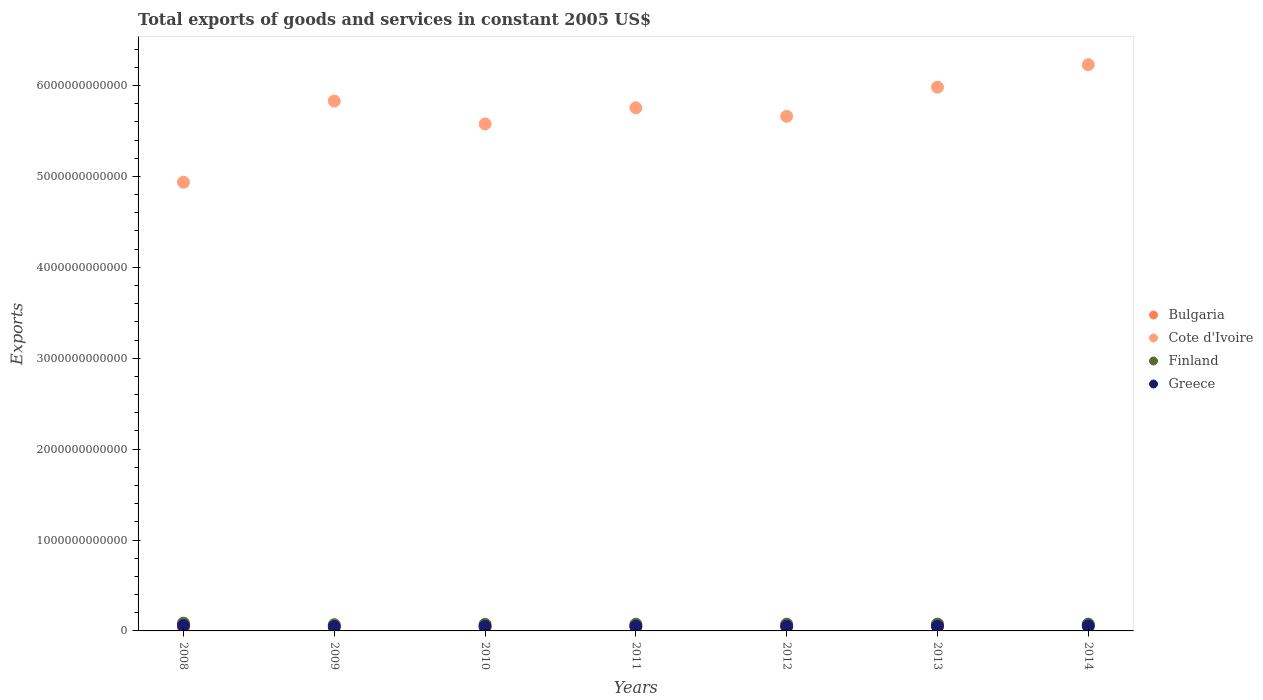How many different coloured dotlines are there?
Ensure brevity in your answer.  4. What is the total exports of goods and services in Finland in 2009?
Provide a succinct answer. 6.82e+1. Across all years, what is the maximum total exports of goods and services in Bulgaria?
Your answer should be very brief. 4.86e+1. Across all years, what is the minimum total exports of goods and services in Bulgaria?
Your answer should be compact. 3.38e+1. In which year was the total exports of goods and services in Finland minimum?
Provide a succinct answer. 2009. What is the total total exports of goods and services in Greece in the graph?
Give a very brief answer. 3.64e+11. What is the difference between the total exports of goods and services in Finland in 2009 and that in 2010?
Provide a succinct answer. -4.21e+09. What is the difference between the total exports of goods and services in Finland in 2008 and the total exports of goods and services in Bulgaria in 2012?
Your answer should be compact. 4.07e+1. What is the average total exports of goods and services in Finland per year?
Your response must be concise. 7.50e+1. In the year 2012, what is the difference between the total exports of goods and services in Finland and total exports of goods and services in Cote d'Ivoire?
Give a very brief answer. -5.59e+12. In how many years, is the total exports of goods and services in Finland greater than 6200000000000 US$?
Make the answer very short. 0. What is the ratio of the total exports of goods and services in Cote d'Ivoire in 2009 to that in 2010?
Offer a very short reply. 1.05. What is the difference between the highest and the second highest total exports of goods and services in Bulgaria?
Keep it short and to the point. 5.41e+07. What is the difference between the highest and the lowest total exports of goods and services in Finland?
Provide a succinct answer. 1.71e+1. Is the sum of the total exports of goods and services in Cote d'Ivoire in 2009 and 2014 greater than the maximum total exports of goods and services in Greece across all years?
Make the answer very short. Yes. Is it the case that in every year, the sum of the total exports of goods and services in Cote d'Ivoire and total exports of goods and services in Greece  is greater than the sum of total exports of goods and services in Bulgaria and total exports of goods and services in Finland?
Keep it short and to the point. No. Does the total exports of goods and services in Bulgaria monotonically increase over the years?
Offer a very short reply. No. Is the total exports of goods and services in Cote d'Ivoire strictly greater than the total exports of goods and services in Bulgaria over the years?
Give a very brief answer. Yes. Is the total exports of goods and services in Finland strictly less than the total exports of goods and services in Bulgaria over the years?
Keep it short and to the point. No. What is the difference between two consecutive major ticks on the Y-axis?
Offer a terse response. 1.00e+12. Does the graph contain any zero values?
Your answer should be compact. No. Does the graph contain grids?
Offer a terse response. No. How many legend labels are there?
Keep it short and to the point. 4. How are the legend labels stacked?
Give a very brief answer. Vertical. What is the title of the graph?
Keep it short and to the point. Total exports of goods and services in constant 2005 US$. What is the label or title of the X-axis?
Keep it short and to the point. Years. What is the label or title of the Y-axis?
Offer a very short reply. Exports. What is the Exports of Bulgaria in 2008?
Your answer should be very brief. 3.83e+1. What is the Exports in Cote d'Ivoire in 2008?
Provide a short and direct response. 4.94e+12. What is the Exports of Finland in 2008?
Your answer should be compact. 8.53e+1. What is the Exports in Greece in 2008?
Give a very brief answer. 5.85e+1. What is the Exports of Bulgaria in 2009?
Your answer should be very brief. 3.38e+1. What is the Exports in Cote d'Ivoire in 2009?
Provide a succinct answer. 5.83e+12. What is the Exports of Finland in 2009?
Offer a very short reply. 6.82e+1. What is the Exports in Greece in 2009?
Your response must be concise. 4.76e+1. What is the Exports in Bulgaria in 2010?
Ensure brevity in your answer.  3.96e+1. What is the Exports of Cote d'Ivoire in 2010?
Provide a short and direct response. 5.58e+12. What is the Exports in Finland in 2010?
Your answer should be compact. 7.24e+1. What is the Exports in Greece in 2010?
Give a very brief answer. 5.00e+1. What is the Exports in Bulgaria in 2011?
Give a very brief answer. 4.42e+1. What is the Exports of Cote d'Ivoire in 2011?
Your answer should be compact. 5.76e+12. What is the Exports in Finland in 2011?
Your answer should be very brief. 7.38e+1. What is the Exports of Greece in 2011?
Your answer should be compact. 5.00e+1. What is the Exports of Bulgaria in 2012?
Your answer should be very brief. 4.46e+1. What is the Exports in Cote d'Ivoire in 2012?
Offer a very short reply. 5.66e+12. What is the Exports of Finland in 2012?
Your answer should be very brief. 7.47e+1. What is the Exports in Greece in 2012?
Make the answer very short. 5.06e+1. What is the Exports of Bulgaria in 2013?
Provide a short and direct response. 4.86e+1. What is the Exports of Cote d'Ivoire in 2013?
Your response must be concise. 5.98e+12. What is the Exports in Finland in 2013?
Give a very brief answer. 7.56e+1. What is the Exports of Greece in 2013?
Your response must be concise. 5.17e+1. What is the Exports of Bulgaria in 2014?
Your answer should be compact. 4.86e+1. What is the Exports in Cote d'Ivoire in 2014?
Keep it short and to the point. 6.23e+12. What is the Exports in Finland in 2014?
Your answer should be very brief. 7.50e+1. What is the Exports in Greece in 2014?
Give a very brief answer. 5.55e+1. Across all years, what is the maximum Exports of Bulgaria?
Offer a terse response. 4.86e+1. Across all years, what is the maximum Exports in Cote d'Ivoire?
Your answer should be very brief. 6.23e+12. Across all years, what is the maximum Exports of Finland?
Offer a very short reply. 8.53e+1. Across all years, what is the maximum Exports of Greece?
Your response must be concise. 5.85e+1. Across all years, what is the minimum Exports in Bulgaria?
Your answer should be very brief. 3.38e+1. Across all years, what is the minimum Exports of Cote d'Ivoire?
Your response must be concise. 4.94e+12. Across all years, what is the minimum Exports in Finland?
Your response must be concise. 6.82e+1. Across all years, what is the minimum Exports of Greece?
Your answer should be compact. 4.76e+1. What is the total Exports of Bulgaria in the graph?
Keep it short and to the point. 2.98e+11. What is the total Exports in Cote d'Ivoire in the graph?
Your answer should be compact. 4.00e+13. What is the total Exports of Finland in the graph?
Make the answer very short. 5.25e+11. What is the total Exports in Greece in the graph?
Keep it short and to the point. 3.64e+11. What is the difference between the Exports in Bulgaria in 2008 and that in 2009?
Keep it short and to the point. 4.49e+09. What is the difference between the Exports in Cote d'Ivoire in 2008 and that in 2009?
Offer a very short reply. -8.94e+11. What is the difference between the Exports of Finland in 2008 and that in 2009?
Provide a succinct answer. 1.71e+1. What is the difference between the Exports of Greece in 2008 and that in 2009?
Offer a very short reply. 1.08e+1. What is the difference between the Exports of Bulgaria in 2008 and that in 2010?
Make the answer very short. -1.33e+09. What is the difference between the Exports in Cote d'Ivoire in 2008 and that in 2010?
Offer a terse response. -6.42e+11. What is the difference between the Exports of Finland in 2008 and that in 2010?
Offer a terse response. 1.29e+1. What is the difference between the Exports in Greece in 2008 and that in 2010?
Make the answer very short. 8.51e+09. What is the difference between the Exports in Bulgaria in 2008 and that in 2011?
Your answer should be compact. -5.89e+09. What is the difference between the Exports of Cote d'Ivoire in 2008 and that in 2011?
Ensure brevity in your answer.  -8.19e+11. What is the difference between the Exports in Finland in 2008 and that in 2011?
Your answer should be very brief. 1.15e+1. What is the difference between the Exports in Greece in 2008 and that in 2011?
Offer a terse response. 8.50e+09. What is the difference between the Exports in Bulgaria in 2008 and that in 2012?
Provide a short and direct response. -6.23e+09. What is the difference between the Exports of Cote d'Ivoire in 2008 and that in 2012?
Offer a very short reply. -7.26e+11. What is the difference between the Exports in Finland in 2008 and that in 2012?
Make the answer very short. 1.06e+1. What is the difference between the Exports in Greece in 2008 and that in 2012?
Your answer should be compact. 7.91e+09. What is the difference between the Exports of Bulgaria in 2008 and that in 2013?
Your answer should be very brief. -1.03e+1. What is the difference between the Exports of Cote d'Ivoire in 2008 and that in 2013?
Ensure brevity in your answer.  -1.05e+12. What is the difference between the Exports in Finland in 2008 and that in 2013?
Keep it short and to the point. 9.71e+09. What is the difference between the Exports of Greece in 2008 and that in 2013?
Your answer should be very brief. 6.82e+09. What is the difference between the Exports in Bulgaria in 2008 and that in 2014?
Ensure brevity in your answer.  -1.03e+1. What is the difference between the Exports of Cote d'Ivoire in 2008 and that in 2014?
Offer a very short reply. -1.29e+12. What is the difference between the Exports of Finland in 2008 and that in 2014?
Offer a terse response. 1.03e+1. What is the difference between the Exports in Greece in 2008 and that in 2014?
Your answer should be compact. 2.96e+09. What is the difference between the Exports of Bulgaria in 2009 and that in 2010?
Offer a terse response. -5.82e+09. What is the difference between the Exports in Cote d'Ivoire in 2009 and that in 2010?
Ensure brevity in your answer.  2.52e+11. What is the difference between the Exports of Finland in 2009 and that in 2010?
Provide a succinct answer. -4.21e+09. What is the difference between the Exports of Greece in 2009 and that in 2010?
Give a very brief answer. -2.32e+09. What is the difference between the Exports of Bulgaria in 2009 and that in 2011?
Your answer should be very brief. -1.04e+1. What is the difference between the Exports in Cote d'Ivoire in 2009 and that in 2011?
Make the answer very short. 7.47e+1. What is the difference between the Exports in Finland in 2009 and that in 2011?
Make the answer very short. -5.65e+09. What is the difference between the Exports of Greece in 2009 and that in 2011?
Offer a very short reply. -2.33e+09. What is the difference between the Exports of Bulgaria in 2009 and that in 2012?
Provide a short and direct response. -1.07e+1. What is the difference between the Exports of Cote d'Ivoire in 2009 and that in 2012?
Your answer should be compact. 1.68e+11. What is the difference between the Exports of Finland in 2009 and that in 2012?
Make the answer very short. -6.56e+09. What is the difference between the Exports of Greece in 2009 and that in 2012?
Offer a very short reply. -2.92e+09. What is the difference between the Exports in Bulgaria in 2009 and that in 2013?
Your answer should be very brief. -1.48e+1. What is the difference between the Exports of Cote d'Ivoire in 2009 and that in 2013?
Keep it short and to the point. -1.53e+11. What is the difference between the Exports of Finland in 2009 and that in 2013?
Make the answer very short. -7.42e+09. What is the difference between the Exports of Greece in 2009 and that in 2013?
Offer a terse response. -4.01e+09. What is the difference between the Exports of Bulgaria in 2009 and that in 2014?
Provide a succinct answer. -1.48e+1. What is the difference between the Exports in Cote d'Ivoire in 2009 and that in 2014?
Your response must be concise. -3.99e+11. What is the difference between the Exports of Finland in 2009 and that in 2014?
Provide a short and direct response. -6.86e+09. What is the difference between the Exports in Greece in 2009 and that in 2014?
Provide a succinct answer. -7.87e+09. What is the difference between the Exports of Bulgaria in 2010 and that in 2011?
Your answer should be compact. -4.56e+09. What is the difference between the Exports of Cote d'Ivoire in 2010 and that in 2011?
Offer a terse response. -1.77e+11. What is the difference between the Exports of Finland in 2010 and that in 2011?
Your answer should be very brief. -1.44e+09. What is the difference between the Exports of Greece in 2010 and that in 2011?
Keep it short and to the point. -1.36e+07. What is the difference between the Exports of Bulgaria in 2010 and that in 2012?
Your answer should be compact. -4.91e+09. What is the difference between the Exports of Cote d'Ivoire in 2010 and that in 2012?
Ensure brevity in your answer.  -8.40e+1. What is the difference between the Exports in Finland in 2010 and that in 2012?
Provide a succinct answer. -2.35e+09. What is the difference between the Exports in Greece in 2010 and that in 2012?
Your answer should be very brief. -6.00e+08. What is the difference between the Exports in Bulgaria in 2010 and that in 2013?
Ensure brevity in your answer.  -9.00e+09. What is the difference between the Exports in Cote d'Ivoire in 2010 and that in 2013?
Provide a succinct answer. -4.04e+11. What is the difference between the Exports of Finland in 2010 and that in 2013?
Keep it short and to the point. -3.21e+09. What is the difference between the Exports in Greece in 2010 and that in 2013?
Provide a succinct answer. -1.70e+09. What is the difference between the Exports of Bulgaria in 2010 and that in 2014?
Provide a succinct answer. -8.95e+09. What is the difference between the Exports in Cote d'Ivoire in 2010 and that in 2014?
Offer a terse response. -6.51e+11. What is the difference between the Exports of Finland in 2010 and that in 2014?
Keep it short and to the point. -2.64e+09. What is the difference between the Exports of Greece in 2010 and that in 2014?
Offer a very short reply. -5.55e+09. What is the difference between the Exports of Bulgaria in 2011 and that in 2012?
Offer a terse response. -3.45e+08. What is the difference between the Exports in Cote d'Ivoire in 2011 and that in 2012?
Give a very brief answer. 9.32e+1. What is the difference between the Exports of Finland in 2011 and that in 2012?
Make the answer very short. -9.15e+08. What is the difference between the Exports in Greece in 2011 and that in 2012?
Offer a terse response. -5.86e+08. What is the difference between the Exports of Bulgaria in 2011 and that in 2013?
Your response must be concise. -4.44e+09. What is the difference between the Exports of Cote d'Ivoire in 2011 and that in 2013?
Your response must be concise. -2.27e+11. What is the difference between the Exports in Finland in 2011 and that in 2013?
Your answer should be very brief. -1.77e+09. What is the difference between the Exports in Greece in 2011 and that in 2013?
Offer a very short reply. -1.68e+09. What is the difference between the Exports of Bulgaria in 2011 and that in 2014?
Your answer should be compact. -4.38e+09. What is the difference between the Exports in Cote d'Ivoire in 2011 and that in 2014?
Offer a terse response. -4.74e+11. What is the difference between the Exports in Finland in 2011 and that in 2014?
Provide a short and direct response. -1.21e+09. What is the difference between the Exports of Greece in 2011 and that in 2014?
Provide a short and direct response. -5.54e+09. What is the difference between the Exports in Bulgaria in 2012 and that in 2013?
Provide a short and direct response. -4.09e+09. What is the difference between the Exports of Cote d'Ivoire in 2012 and that in 2013?
Ensure brevity in your answer.  -3.20e+11. What is the difference between the Exports of Finland in 2012 and that in 2013?
Provide a succinct answer. -8.58e+08. What is the difference between the Exports in Greece in 2012 and that in 2013?
Your answer should be very brief. -1.10e+09. What is the difference between the Exports of Bulgaria in 2012 and that in 2014?
Provide a succinct answer. -4.04e+09. What is the difference between the Exports in Cote d'Ivoire in 2012 and that in 2014?
Give a very brief answer. -5.67e+11. What is the difference between the Exports in Finland in 2012 and that in 2014?
Give a very brief answer. -2.92e+08. What is the difference between the Exports in Greece in 2012 and that in 2014?
Provide a short and direct response. -4.95e+09. What is the difference between the Exports of Bulgaria in 2013 and that in 2014?
Make the answer very short. 5.41e+07. What is the difference between the Exports of Cote d'Ivoire in 2013 and that in 2014?
Your answer should be compact. -2.47e+11. What is the difference between the Exports in Finland in 2013 and that in 2014?
Provide a succinct answer. 5.66e+08. What is the difference between the Exports of Greece in 2013 and that in 2014?
Your response must be concise. -3.86e+09. What is the difference between the Exports of Bulgaria in 2008 and the Exports of Cote d'Ivoire in 2009?
Ensure brevity in your answer.  -5.79e+12. What is the difference between the Exports of Bulgaria in 2008 and the Exports of Finland in 2009?
Provide a succinct answer. -2.98e+1. What is the difference between the Exports of Bulgaria in 2008 and the Exports of Greece in 2009?
Keep it short and to the point. -9.32e+09. What is the difference between the Exports in Cote d'Ivoire in 2008 and the Exports in Finland in 2009?
Ensure brevity in your answer.  4.87e+12. What is the difference between the Exports of Cote d'Ivoire in 2008 and the Exports of Greece in 2009?
Give a very brief answer. 4.89e+12. What is the difference between the Exports in Finland in 2008 and the Exports in Greece in 2009?
Give a very brief answer. 3.76e+1. What is the difference between the Exports in Bulgaria in 2008 and the Exports in Cote d'Ivoire in 2010?
Give a very brief answer. -5.54e+12. What is the difference between the Exports of Bulgaria in 2008 and the Exports of Finland in 2010?
Your answer should be compact. -3.40e+1. What is the difference between the Exports in Bulgaria in 2008 and the Exports in Greece in 2010?
Offer a terse response. -1.16e+1. What is the difference between the Exports of Cote d'Ivoire in 2008 and the Exports of Finland in 2010?
Give a very brief answer. 4.86e+12. What is the difference between the Exports in Cote d'Ivoire in 2008 and the Exports in Greece in 2010?
Ensure brevity in your answer.  4.89e+12. What is the difference between the Exports of Finland in 2008 and the Exports of Greece in 2010?
Your answer should be very brief. 3.53e+1. What is the difference between the Exports in Bulgaria in 2008 and the Exports in Cote d'Ivoire in 2011?
Your answer should be very brief. -5.72e+12. What is the difference between the Exports in Bulgaria in 2008 and the Exports in Finland in 2011?
Offer a terse response. -3.55e+1. What is the difference between the Exports in Bulgaria in 2008 and the Exports in Greece in 2011?
Provide a short and direct response. -1.16e+1. What is the difference between the Exports in Cote d'Ivoire in 2008 and the Exports in Finland in 2011?
Keep it short and to the point. 4.86e+12. What is the difference between the Exports of Cote d'Ivoire in 2008 and the Exports of Greece in 2011?
Offer a very short reply. 4.89e+12. What is the difference between the Exports in Finland in 2008 and the Exports in Greece in 2011?
Offer a very short reply. 3.53e+1. What is the difference between the Exports in Bulgaria in 2008 and the Exports in Cote d'Ivoire in 2012?
Keep it short and to the point. -5.62e+12. What is the difference between the Exports in Bulgaria in 2008 and the Exports in Finland in 2012?
Make the answer very short. -3.64e+1. What is the difference between the Exports of Bulgaria in 2008 and the Exports of Greece in 2012?
Your answer should be very brief. -1.22e+1. What is the difference between the Exports in Cote d'Ivoire in 2008 and the Exports in Finland in 2012?
Give a very brief answer. 4.86e+12. What is the difference between the Exports of Cote d'Ivoire in 2008 and the Exports of Greece in 2012?
Your answer should be very brief. 4.89e+12. What is the difference between the Exports in Finland in 2008 and the Exports in Greece in 2012?
Offer a very short reply. 3.47e+1. What is the difference between the Exports of Bulgaria in 2008 and the Exports of Cote d'Ivoire in 2013?
Offer a very short reply. -5.94e+12. What is the difference between the Exports of Bulgaria in 2008 and the Exports of Finland in 2013?
Your answer should be compact. -3.73e+1. What is the difference between the Exports of Bulgaria in 2008 and the Exports of Greece in 2013?
Provide a succinct answer. -1.33e+1. What is the difference between the Exports in Cote d'Ivoire in 2008 and the Exports in Finland in 2013?
Keep it short and to the point. 4.86e+12. What is the difference between the Exports of Cote d'Ivoire in 2008 and the Exports of Greece in 2013?
Offer a very short reply. 4.88e+12. What is the difference between the Exports in Finland in 2008 and the Exports in Greece in 2013?
Offer a terse response. 3.36e+1. What is the difference between the Exports of Bulgaria in 2008 and the Exports of Cote d'Ivoire in 2014?
Provide a short and direct response. -6.19e+12. What is the difference between the Exports in Bulgaria in 2008 and the Exports in Finland in 2014?
Offer a very short reply. -3.67e+1. What is the difference between the Exports of Bulgaria in 2008 and the Exports of Greece in 2014?
Your answer should be compact. -1.72e+1. What is the difference between the Exports in Cote d'Ivoire in 2008 and the Exports in Finland in 2014?
Your response must be concise. 4.86e+12. What is the difference between the Exports of Cote d'Ivoire in 2008 and the Exports of Greece in 2014?
Offer a terse response. 4.88e+12. What is the difference between the Exports of Finland in 2008 and the Exports of Greece in 2014?
Provide a short and direct response. 2.98e+1. What is the difference between the Exports of Bulgaria in 2009 and the Exports of Cote d'Ivoire in 2010?
Keep it short and to the point. -5.54e+12. What is the difference between the Exports of Bulgaria in 2009 and the Exports of Finland in 2010?
Your answer should be compact. -3.85e+1. What is the difference between the Exports in Bulgaria in 2009 and the Exports in Greece in 2010?
Ensure brevity in your answer.  -1.61e+1. What is the difference between the Exports of Cote d'Ivoire in 2009 and the Exports of Finland in 2010?
Keep it short and to the point. 5.76e+12. What is the difference between the Exports of Cote d'Ivoire in 2009 and the Exports of Greece in 2010?
Keep it short and to the point. 5.78e+12. What is the difference between the Exports of Finland in 2009 and the Exports of Greece in 2010?
Provide a short and direct response. 1.82e+1. What is the difference between the Exports of Bulgaria in 2009 and the Exports of Cote d'Ivoire in 2011?
Give a very brief answer. -5.72e+12. What is the difference between the Exports of Bulgaria in 2009 and the Exports of Finland in 2011?
Make the answer very short. -4.00e+1. What is the difference between the Exports in Bulgaria in 2009 and the Exports in Greece in 2011?
Make the answer very short. -1.61e+1. What is the difference between the Exports of Cote d'Ivoire in 2009 and the Exports of Finland in 2011?
Make the answer very short. 5.76e+12. What is the difference between the Exports of Cote d'Ivoire in 2009 and the Exports of Greece in 2011?
Keep it short and to the point. 5.78e+12. What is the difference between the Exports in Finland in 2009 and the Exports in Greece in 2011?
Ensure brevity in your answer.  1.82e+1. What is the difference between the Exports in Bulgaria in 2009 and the Exports in Cote d'Ivoire in 2012?
Ensure brevity in your answer.  -5.63e+12. What is the difference between the Exports in Bulgaria in 2009 and the Exports in Finland in 2012?
Offer a very short reply. -4.09e+1. What is the difference between the Exports in Bulgaria in 2009 and the Exports in Greece in 2012?
Your answer should be very brief. -1.67e+1. What is the difference between the Exports of Cote d'Ivoire in 2009 and the Exports of Finland in 2012?
Ensure brevity in your answer.  5.75e+12. What is the difference between the Exports of Cote d'Ivoire in 2009 and the Exports of Greece in 2012?
Ensure brevity in your answer.  5.78e+12. What is the difference between the Exports in Finland in 2009 and the Exports in Greece in 2012?
Provide a succinct answer. 1.76e+1. What is the difference between the Exports in Bulgaria in 2009 and the Exports in Cote d'Ivoire in 2013?
Keep it short and to the point. -5.95e+12. What is the difference between the Exports of Bulgaria in 2009 and the Exports of Finland in 2013?
Offer a terse response. -4.17e+1. What is the difference between the Exports in Bulgaria in 2009 and the Exports in Greece in 2013?
Offer a very short reply. -1.78e+1. What is the difference between the Exports of Cote d'Ivoire in 2009 and the Exports of Finland in 2013?
Provide a succinct answer. 5.75e+12. What is the difference between the Exports in Cote d'Ivoire in 2009 and the Exports in Greece in 2013?
Provide a short and direct response. 5.78e+12. What is the difference between the Exports in Finland in 2009 and the Exports in Greece in 2013?
Ensure brevity in your answer.  1.65e+1. What is the difference between the Exports in Bulgaria in 2009 and the Exports in Cote d'Ivoire in 2014?
Provide a succinct answer. -6.20e+12. What is the difference between the Exports in Bulgaria in 2009 and the Exports in Finland in 2014?
Your response must be concise. -4.12e+1. What is the difference between the Exports in Bulgaria in 2009 and the Exports in Greece in 2014?
Offer a very short reply. -2.17e+1. What is the difference between the Exports of Cote d'Ivoire in 2009 and the Exports of Finland in 2014?
Provide a short and direct response. 5.75e+12. What is the difference between the Exports of Cote d'Ivoire in 2009 and the Exports of Greece in 2014?
Your response must be concise. 5.77e+12. What is the difference between the Exports in Finland in 2009 and the Exports in Greece in 2014?
Make the answer very short. 1.26e+1. What is the difference between the Exports in Bulgaria in 2010 and the Exports in Cote d'Ivoire in 2011?
Provide a short and direct response. -5.72e+12. What is the difference between the Exports in Bulgaria in 2010 and the Exports in Finland in 2011?
Give a very brief answer. -3.42e+1. What is the difference between the Exports in Bulgaria in 2010 and the Exports in Greece in 2011?
Provide a short and direct response. -1.03e+1. What is the difference between the Exports of Cote d'Ivoire in 2010 and the Exports of Finland in 2011?
Your response must be concise. 5.50e+12. What is the difference between the Exports of Cote d'Ivoire in 2010 and the Exports of Greece in 2011?
Offer a very short reply. 5.53e+12. What is the difference between the Exports of Finland in 2010 and the Exports of Greece in 2011?
Your answer should be compact. 2.24e+1. What is the difference between the Exports in Bulgaria in 2010 and the Exports in Cote d'Ivoire in 2012?
Provide a succinct answer. -5.62e+12. What is the difference between the Exports in Bulgaria in 2010 and the Exports in Finland in 2012?
Give a very brief answer. -3.51e+1. What is the difference between the Exports of Bulgaria in 2010 and the Exports of Greece in 2012?
Keep it short and to the point. -1.09e+1. What is the difference between the Exports in Cote d'Ivoire in 2010 and the Exports in Finland in 2012?
Your answer should be compact. 5.50e+12. What is the difference between the Exports of Cote d'Ivoire in 2010 and the Exports of Greece in 2012?
Provide a succinct answer. 5.53e+12. What is the difference between the Exports in Finland in 2010 and the Exports in Greece in 2012?
Keep it short and to the point. 2.18e+1. What is the difference between the Exports in Bulgaria in 2010 and the Exports in Cote d'Ivoire in 2013?
Give a very brief answer. -5.94e+12. What is the difference between the Exports of Bulgaria in 2010 and the Exports of Finland in 2013?
Provide a succinct answer. -3.59e+1. What is the difference between the Exports of Bulgaria in 2010 and the Exports of Greece in 2013?
Offer a terse response. -1.20e+1. What is the difference between the Exports in Cote d'Ivoire in 2010 and the Exports in Finland in 2013?
Offer a very short reply. 5.50e+12. What is the difference between the Exports of Cote d'Ivoire in 2010 and the Exports of Greece in 2013?
Provide a succinct answer. 5.53e+12. What is the difference between the Exports in Finland in 2010 and the Exports in Greece in 2013?
Your response must be concise. 2.07e+1. What is the difference between the Exports of Bulgaria in 2010 and the Exports of Cote d'Ivoire in 2014?
Ensure brevity in your answer.  -6.19e+12. What is the difference between the Exports of Bulgaria in 2010 and the Exports of Finland in 2014?
Your answer should be very brief. -3.54e+1. What is the difference between the Exports of Bulgaria in 2010 and the Exports of Greece in 2014?
Give a very brief answer. -1.59e+1. What is the difference between the Exports of Cote d'Ivoire in 2010 and the Exports of Finland in 2014?
Offer a terse response. 5.50e+12. What is the difference between the Exports of Cote d'Ivoire in 2010 and the Exports of Greece in 2014?
Offer a very short reply. 5.52e+12. What is the difference between the Exports in Finland in 2010 and the Exports in Greece in 2014?
Ensure brevity in your answer.  1.69e+1. What is the difference between the Exports of Bulgaria in 2011 and the Exports of Cote d'Ivoire in 2012?
Keep it short and to the point. -5.62e+12. What is the difference between the Exports of Bulgaria in 2011 and the Exports of Finland in 2012?
Offer a very short reply. -3.05e+1. What is the difference between the Exports in Bulgaria in 2011 and the Exports in Greece in 2012?
Keep it short and to the point. -6.35e+09. What is the difference between the Exports in Cote d'Ivoire in 2011 and the Exports in Finland in 2012?
Your answer should be compact. 5.68e+12. What is the difference between the Exports of Cote d'Ivoire in 2011 and the Exports of Greece in 2012?
Offer a very short reply. 5.70e+12. What is the difference between the Exports in Finland in 2011 and the Exports in Greece in 2012?
Keep it short and to the point. 2.32e+1. What is the difference between the Exports in Bulgaria in 2011 and the Exports in Cote d'Ivoire in 2013?
Provide a short and direct response. -5.94e+12. What is the difference between the Exports of Bulgaria in 2011 and the Exports of Finland in 2013?
Ensure brevity in your answer.  -3.14e+1. What is the difference between the Exports of Bulgaria in 2011 and the Exports of Greece in 2013?
Provide a succinct answer. -7.44e+09. What is the difference between the Exports in Cote d'Ivoire in 2011 and the Exports in Finland in 2013?
Offer a terse response. 5.68e+12. What is the difference between the Exports in Cote d'Ivoire in 2011 and the Exports in Greece in 2013?
Keep it short and to the point. 5.70e+12. What is the difference between the Exports in Finland in 2011 and the Exports in Greece in 2013?
Your answer should be very brief. 2.21e+1. What is the difference between the Exports of Bulgaria in 2011 and the Exports of Cote d'Ivoire in 2014?
Provide a short and direct response. -6.18e+12. What is the difference between the Exports of Bulgaria in 2011 and the Exports of Finland in 2014?
Provide a succinct answer. -3.08e+1. What is the difference between the Exports of Bulgaria in 2011 and the Exports of Greece in 2014?
Ensure brevity in your answer.  -1.13e+1. What is the difference between the Exports in Cote d'Ivoire in 2011 and the Exports in Finland in 2014?
Ensure brevity in your answer.  5.68e+12. What is the difference between the Exports in Cote d'Ivoire in 2011 and the Exports in Greece in 2014?
Provide a succinct answer. 5.70e+12. What is the difference between the Exports of Finland in 2011 and the Exports of Greece in 2014?
Ensure brevity in your answer.  1.83e+1. What is the difference between the Exports of Bulgaria in 2012 and the Exports of Cote d'Ivoire in 2013?
Your answer should be compact. -5.94e+12. What is the difference between the Exports in Bulgaria in 2012 and the Exports in Finland in 2013?
Your response must be concise. -3.10e+1. What is the difference between the Exports in Bulgaria in 2012 and the Exports in Greece in 2013?
Provide a short and direct response. -7.10e+09. What is the difference between the Exports of Cote d'Ivoire in 2012 and the Exports of Finland in 2013?
Offer a very short reply. 5.59e+12. What is the difference between the Exports in Cote d'Ivoire in 2012 and the Exports in Greece in 2013?
Give a very brief answer. 5.61e+12. What is the difference between the Exports of Finland in 2012 and the Exports of Greece in 2013?
Give a very brief answer. 2.31e+1. What is the difference between the Exports of Bulgaria in 2012 and the Exports of Cote d'Ivoire in 2014?
Your response must be concise. -6.18e+12. What is the difference between the Exports in Bulgaria in 2012 and the Exports in Finland in 2014?
Keep it short and to the point. -3.05e+1. What is the difference between the Exports in Bulgaria in 2012 and the Exports in Greece in 2014?
Make the answer very short. -1.10e+1. What is the difference between the Exports of Cote d'Ivoire in 2012 and the Exports of Finland in 2014?
Provide a succinct answer. 5.59e+12. What is the difference between the Exports of Cote d'Ivoire in 2012 and the Exports of Greece in 2014?
Provide a succinct answer. 5.61e+12. What is the difference between the Exports in Finland in 2012 and the Exports in Greece in 2014?
Your answer should be very brief. 1.92e+1. What is the difference between the Exports in Bulgaria in 2013 and the Exports in Cote d'Ivoire in 2014?
Keep it short and to the point. -6.18e+12. What is the difference between the Exports in Bulgaria in 2013 and the Exports in Finland in 2014?
Give a very brief answer. -2.64e+1. What is the difference between the Exports in Bulgaria in 2013 and the Exports in Greece in 2014?
Give a very brief answer. -6.86e+09. What is the difference between the Exports in Cote d'Ivoire in 2013 and the Exports in Finland in 2014?
Your answer should be compact. 5.91e+12. What is the difference between the Exports in Cote d'Ivoire in 2013 and the Exports in Greece in 2014?
Your response must be concise. 5.93e+12. What is the difference between the Exports of Finland in 2013 and the Exports of Greece in 2014?
Your response must be concise. 2.01e+1. What is the average Exports of Bulgaria per year?
Keep it short and to the point. 4.25e+1. What is the average Exports of Cote d'Ivoire per year?
Provide a short and direct response. 5.71e+12. What is the average Exports of Finland per year?
Ensure brevity in your answer.  7.50e+1. What is the average Exports in Greece per year?
Provide a succinct answer. 5.20e+1. In the year 2008, what is the difference between the Exports of Bulgaria and Exports of Cote d'Ivoire?
Your answer should be compact. -4.90e+12. In the year 2008, what is the difference between the Exports of Bulgaria and Exports of Finland?
Your answer should be compact. -4.70e+1. In the year 2008, what is the difference between the Exports in Bulgaria and Exports in Greece?
Keep it short and to the point. -2.01e+1. In the year 2008, what is the difference between the Exports of Cote d'Ivoire and Exports of Finland?
Provide a short and direct response. 4.85e+12. In the year 2008, what is the difference between the Exports of Cote d'Ivoire and Exports of Greece?
Ensure brevity in your answer.  4.88e+12. In the year 2008, what is the difference between the Exports in Finland and Exports in Greece?
Offer a terse response. 2.68e+1. In the year 2009, what is the difference between the Exports in Bulgaria and Exports in Cote d'Ivoire?
Keep it short and to the point. -5.80e+12. In the year 2009, what is the difference between the Exports of Bulgaria and Exports of Finland?
Your answer should be compact. -3.43e+1. In the year 2009, what is the difference between the Exports of Bulgaria and Exports of Greece?
Keep it short and to the point. -1.38e+1. In the year 2009, what is the difference between the Exports of Cote d'Ivoire and Exports of Finland?
Your answer should be very brief. 5.76e+12. In the year 2009, what is the difference between the Exports of Cote d'Ivoire and Exports of Greece?
Offer a very short reply. 5.78e+12. In the year 2009, what is the difference between the Exports of Finland and Exports of Greece?
Ensure brevity in your answer.  2.05e+1. In the year 2010, what is the difference between the Exports of Bulgaria and Exports of Cote d'Ivoire?
Offer a very short reply. -5.54e+12. In the year 2010, what is the difference between the Exports of Bulgaria and Exports of Finland?
Make the answer very short. -3.27e+1. In the year 2010, what is the difference between the Exports in Bulgaria and Exports in Greece?
Your answer should be compact. -1.03e+1. In the year 2010, what is the difference between the Exports in Cote d'Ivoire and Exports in Finland?
Your response must be concise. 5.51e+12. In the year 2010, what is the difference between the Exports of Cote d'Ivoire and Exports of Greece?
Your answer should be compact. 5.53e+12. In the year 2010, what is the difference between the Exports of Finland and Exports of Greece?
Provide a short and direct response. 2.24e+1. In the year 2011, what is the difference between the Exports in Bulgaria and Exports in Cote d'Ivoire?
Ensure brevity in your answer.  -5.71e+12. In the year 2011, what is the difference between the Exports in Bulgaria and Exports in Finland?
Provide a succinct answer. -2.96e+1. In the year 2011, what is the difference between the Exports of Bulgaria and Exports of Greece?
Offer a very short reply. -5.76e+09. In the year 2011, what is the difference between the Exports in Cote d'Ivoire and Exports in Finland?
Offer a very short reply. 5.68e+12. In the year 2011, what is the difference between the Exports of Cote d'Ivoire and Exports of Greece?
Your answer should be compact. 5.71e+12. In the year 2011, what is the difference between the Exports of Finland and Exports of Greece?
Offer a very short reply. 2.38e+1. In the year 2012, what is the difference between the Exports of Bulgaria and Exports of Cote d'Ivoire?
Keep it short and to the point. -5.62e+12. In the year 2012, what is the difference between the Exports of Bulgaria and Exports of Finland?
Keep it short and to the point. -3.02e+1. In the year 2012, what is the difference between the Exports of Bulgaria and Exports of Greece?
Ensure brevity in your answer.  -6.00e+09. In the year 2012, what is the difference between the Exports of Cote d'Ivoire and Exports of Finland?
Offer a very short reply. 5.59e+12. In the year 2012, what is the difference between the Exports in Cote d'Ivoire and Exports in Greece?
Your response must be concise. 5.61e+12. In the year 2012, what is the difference between the Exports in Finland and Exports in Greece?
Make the answer very short. 2.42e+1. In the year 2013, what is the difference between the Exports in Bulgaria and Exports in Cote d'Ivoire?
Ensure brevity in your answer.  -5.93e+12. In the year 2013, what is the difference between the Exports in Bulgaria and Exports in Finland?
Your response must be concise. -2.69e+1. In the year 2013, what is the difference between the Exports of Bulgaria and Exports of Greece?
Your response must be concise. -3.01e+09. In the year 2013, what is the difference between the Exports of Cote d'Ivoire and Exports of Finland?
Offer a terse response. 5.91e+12. In the year 2013, what is the difference between the Exports in Cote d'Ivoire and Exports in Greece?
Provide a short and direct response. 5.93e+12. In the year 2013, what is the difference between the Exports of Finland and Exports of Greece?
Provide a succinct answer. 2.39e+1. In the year 2014, what is the difference between the Exports in Bulgaria and Exports in Cote d'Ivoire?
Keep it short and to the point. -6.18e+12. In the year 2014, what is the difference between the Exports of Bulgaria and Exports of Finland?
Provide a succinct answer. -2.64e+1. In the year 2014, what is the difference between the Exports in Bulgaria and Exports in Greece?
Offer a terse response. -6.92e+09. In the year 2014, what is the difference between the Exports in Cote d'Ivoire and Exports in Finland?
Give a very brief answer. 6.15e+12. In the year 2014, what is the difference between the Exports in Cote d'Ivoire and Exports in Greece?
Offer a terse response. 6.17e+12. In the year 2014, what is the difference between the Exports in Finland and Exports in Greece?
Make the answer very short. 1.95e+1. What is the ratio of the Exports of Bulgaria in 2008 to that in 2009?
Keep it short and to the point. 1.13. What is the ratio of the Exports in Cote d'Ivoire in 2008 to that in 2009?
Your answer should be compact. 0.85. What is the ratio of the Exports in Finland in 2008 to that in 2009?
Your response must be concise. 1.25. What is the ratio of the Exports of Greece in 2008 to that in 2009?
Keep it short and to the point. 1.23. What is the ratio of the Exports of Bulgaria in 2008 to that in 2010?
Make the answer very short. 0.97. What is the ratio of the Exports of Cote d'Ivoire in 2008 to that in 2010?
Offer a very short reply. 0.89. What is the ratio of the Exports in Finland in 2008 to that in 2010?
Keep it short and to the point. 1.18. What is the ratio of the Exports in Greece in 2008 to that in 2010?
Offer a terse response. 1.17. What is the ratio of the Exports of Bulgaria in 2008 to that in 2011?
Your answer should be compact. 0.87. What is the ratio of the Exports in Cote d'Ivoire in 2008 to that in 2011?
Keep it short and to the point. 0.86. What is the ratio of the Exports in Finland in 2008 to that in 2011?
Offer a terse response. 1.16. What is the ratio of the Exports of Greece in 2008 to that in 2011?
Provide a short and direct response. 1.17. What is the ratio of the Exports of Bulgaria in 2008 to that in 2012?
Give a very brief answer. 0.86. What is the ratio of the Exports of Cote d'Ivoire in 2008 to that in 2012?
Provide a short and direct response. 0.87. What is the ratio of the Exports in Finland in 2008 to that in 2012?
Make the answer very short. 1.14. What is the ratio of the Exports of Greece in 2008 to that in 2012?
Provide a succinct answer. 1.16. What is the ratio of the Exports of Bulgaria in 2008 to that in 2013?
Provide a succinct answer. 0.79. What is the ratio of the Exports of Cote d'Ivoire in 2008 to that in 2013?
Keep it short and to the point. 0.83. What is the ratio of the Exports in Finland in 2008 to that in 2013?
Offer a terse response. 1.13. What is the ratio of the Exports of Greece in 2008 to that in 2013?
Your response must be concise. 1.13. What is the ratio of the Exports of Bulgaria in 2008 to that in 2014?
Your response must be concise. 0.79. What is the ratio of the Exports of Cote d'Ivoire in 2008 to that in 2014?
Provide a succinct answer. 0.79. What is the ratio of the Exports in Finland in 2008 to that in 2014?
Offer a very short reply. 1.14. What is the ratio of the Exports of Greece in 2008 to that in 2014?
Provide a succinct answer. 1.05. What is the ratio of the Exports of Bulgaria in 2009 to that in 2010?
Offer a terse response. 0.85. What is the ratio of the Exports in Cote d'Ivoire in 2009 to that in 2010?
Ensure brevity in your answer.  1.05. What is the ratio of the Exports in Finland in 2009 to that in 2010?
Make the answer very short. 0.94. What is the ratio of the Exports in Greece in 2009 to that in 2010?
Your answer should be compact. 0.95. What is the ratio of the Exports in Bulgaria in 2009 to that in 2011?
Give a very brief answer. 0.77. What is the ratio of the Exports in Cote d'Ivoire in 2009 to that in 2011?
Your response must be concise. 1.01. What is the ratio of the Exports in Finland in 2009 to that in 2011?
Your response must be concise. 0.92. What is the ratio of the Exports of Greece in 2009 to that in 2011?
Your response must be concise. 0.95. What is the ratio of the Exports in Bulgaria in 2009 to that in 2012?
Give a very brief answer. 0.76. What is the ratio of the Exports of Cote d'Ivoire in 2009 to that in 2012?
Keep it short and to the point. 1.03. What is the ratio of the Exports in Finland in 2009 to that in 2012?
Ensure brevity in your answer.  0.91. What is the ratio of the Exports of Greece in 2009 to that in 2012?
Offer a terse response. 0.94. What is the ratio of the Exports of Bulgaria in 2009 to that in 2013?
Make the answer very short. 0.7. What is the ratio of the Exports in Cote d'Ivoire in 2009 to that in 2013?
Offer a terse response. 0.97. What is the ratio of the Exports of Finland in 2009 to that in 2013?
Make the answer very short. 0.9. What is the ratio of the Exports in Greece in 2009 to that in 2013?
Your answer should be very brief. 0.92. What is the ratio of the Exports of Bulgaria in 2009 to that in 2014?
Your answer should be compact. 0.7. What is the ratio of the Exports of Cote d'Ivoire in 2009 to that in 2014?
Provide a succinct answer. 0.94. What is the ratio of the Exports in Finland in 2009 to that in 2014?
Ensure brevity in your answer.  0.91. What is the ratio of the Exports of Greece in 2009 to that in 2014?
Your answer should be very brief. 0.86. What is the ratio of the Exports in Bulgaria in 2010 to that in 2011?
Make the answer very short. 0.9. What is the ratio of the Exports in Cote d'Ivoire in 2010 to that in 2011?
Give a very brief answer. 0.97. What is the ratio of the Exports in Finland in 2010 to that in 2011?
Your answer should be very brief. 0.98. What is the ratio of the Exports of Bulgaria in 2010 to that in 2012?
Your answer should be compact. 0.89. What is the ratio of the Exports of Cote d'Ivoire in 2010 to that in 2012?
Offer a very short reply. 0.99. What is the ratio of the Exports of Finland in 2010 to that in 2012?
Offer a very short reply. 0.97. What is the ratio of the Exports in Bulgaria in 2010 to that in 2013?
Your answer should be compact. 0.81. What is the ratio of the Exports of Cote d'Ivoire in 2010 to that in 2013?
Offer a terse response. 0.93. What is the ratio of the Exports of Finland in 2010 to that in 2013?
Provide a short and direct response. 0.96. What is the ratio of the Exports of Greece in 2010 to that in 2013?
Ensure brevity in your answer.  0.97. What is the ratio of the Exports in Bulgaria in 2010 to that in 2014?
Your answer should be very brief. 0.82. What is the ratio of the Exports in Cote d'Ivoire in 2010 to that in 2014?
Provide a succinct answer. 0.9. What is the ratio of the Exports of Finland in 2010 to that in 2014?
Give a very brief answer. 0.96. What is the ratio of the Exports in Cote d'Ivoire in 2011 to that in 2012?
Keep it short and to the point. 1.02. What is the ratio of the Exports in Finland in 2011 to that in 2012?
Your answer should be very brief. 0.99. What is the ratio of the Exports of Greece in 2011 to that in 2012?
Keep it short and to the point. 0.99. What is the ratio of the Exports in Bulgaria in 2011 to that in 2013?
Keep it short and to the point. 0.91. What is the ratio of the Exports in Cote d'Ivoire in 2011 to that in 2013?
Provide a succinct answer. 0.96. What is the ratio of the Exports in Finland in 2011 to that in 2013?
Your answer should be compact. 0.98. What is the ratio of the Exports in Greece in 2011 to that in 2013?
Provide a short and direct response. 0.97. What is the ratio of the Exports of Bulgaria in 2011 to that in 2014?
Your answer should be compact. 0.91. What is the ratio of the Exports of Cote d'Ivoire in 2011 to that in 2014?
Your answer should be compact. 0.92. What is the ratio of the Exports of Finland in 2011 to that in 2014?
Provide a succinct answer. 0.98. What is the ratio of the Exports in Greece in 2011 to that in 2014?
Ensure brevity in your answer.  0.9. What is the ratio of the Exports of Bulgaria in 2012 to that in 2013?
Offer a terse response. 0.92. What is the ratio of the Exports of Cote d'Ivoire in 2012 to that in 2013?
Ensure brevity in your answer.  0.95. What is the ratio of the Exports of Greece in 2012 to that in 2013?
Your answer should be compact. 0.98. What is the ratio of the Exports in Bulgaria in 2012 to that in 2014?
Offer a terse response. 0.92. What is the ratio of the Exports of Cote d'Ivoire in 2012 to that in 2014?
Make the answer very short. 0.91. What is the ratio of the Exports of Finland in 2012 to that in 2014?
Ensure brevity in your answer.  1. What is the ratio of the Exports in Greece in 2012 to that in 2014?
Your response must be concise. 0.91. What is the ratio of the Exports of Bulgaria in 2013 to that in 2014?
Your response must be concise. 1. What is the ratio of the Exports in Cote d'Ivoire in 2013 to that in 2014?
Provide a succinct answer. 0.96. What is the ratio of the Exports in Finland in 2013 to that in 2014?
Your response must be concise. 1.01. What is the ratio of the Exports in Greece in 2013 to that in 2014?
Your answer should be very brief. 0.93. What is the difference between the highest and the second highest Exports in Bulgaria?
Ensure brevity in your answer.  5.41e+07. What is the difference between the highest and the second highest Exports in Cote d'Ivoire?
Give a very brief answer. 2.47e+11. What is the difference between the highest and the second highest Exports in Finland?
Give a very brief answer. 9.71e+09. What is the difference between the highest and the second highest Exports of Greece?
Provide a succinct answer. 2.96e+09. What is the difference between the highest and the lowest Exports in Bulgaria?
Give a very brief answer. 1.48e+1. What is the difference between the highest and the lowest Exports in Cote d'Ivoire?
Make the answer very short. 1.29e+12. What is the difference between the highest and the lowest Exports in Finland?
Make the answer very short. 1.71e+1. What is the difference between the highest and the lowest Exports of Greece?
Give a very brief answer. 1.08e+1. 